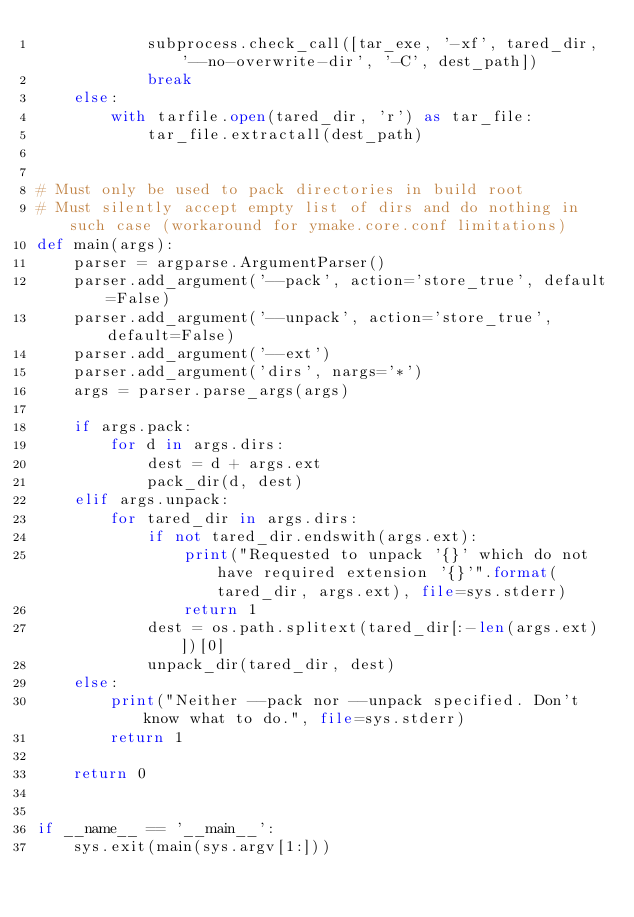Convert code to text. <code><loc_0><loc_0><loc_500><loc_500><_Python_>            subprocess.check_call([tar_exe, '-xf', tared_dir, '--no-overwrite-dir', '-C', dest_path])
            break
    else:
        with tarfile.open(tared_dir, 'r') as tar_file:
            tar_file.extractall(dest_path)


# Must only be used to pack directories in build root
# Must silently accept empty list of dirs and do nothing in such case (workaround for ymake.core.conf limitations)
def main(args):
    parser = argparse.ArgumentParser()
    parser.add_argument('--pack', action='store_true', default=False)
    parser.add_argument('--unpack', action='store_true', default=False)
    parser.add_argument('--ext')
    parser.add_argument('dirs', nargs='*')
    args = parser.parse_args(args)

    if args.pack:
        for d in args.dirs:
            dest = d + args.ext
            pack_dir(d, dest)
    elif args.unpack:
        for tared_dir in args.dirs:
            if not tared_dir.endswith(args.ext):
                print("Requested to unpack '{}' which do not have required extension '{}'".format(tared_dir, args.ext), file=sys.stderr)
                return 1
            dest = os.path.splitext(tared_dir[:-len(args.ext)])[0]
            unpack_dir(tared_dir, dest)
    else:
        print("Neither --pack nor --unpack specified. Don't know what to do.", file=sys.stderr)
        return 1

    return 0


if __name__ == '__main__':
    sys.exit(main(sys.argv[1:]))
</code> 